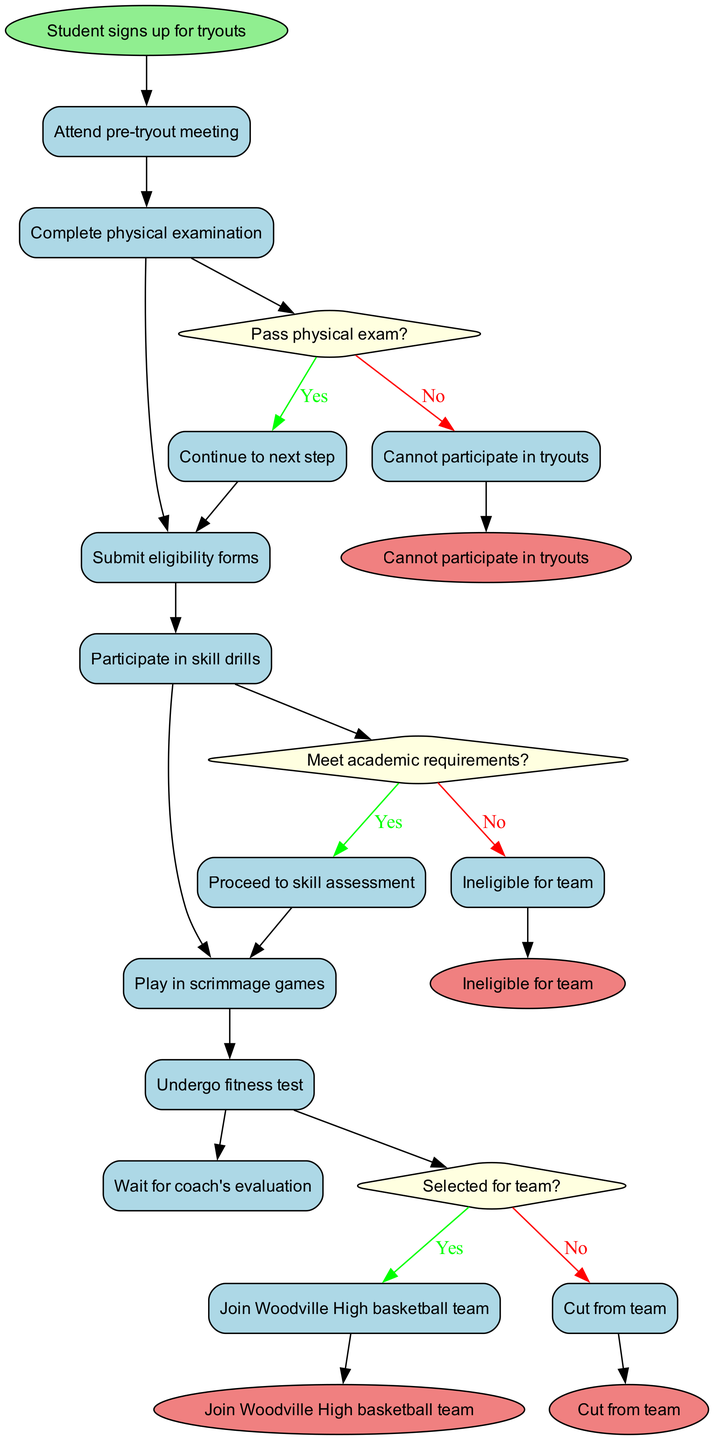What is the starting node of the process? The starting node is defined at the beginning of the diagram, labeled "Student signs up for tryouts."
Answer: Student signs up for tryouts How many activities are listed in the diagram? The activities section includes a list of seven activities, counted directly from the diagram.
Answer: 7 What happens if a student does not pass the physical examination? According to the decision in the diagram, if the physical exam is not passed, the student cannot participate in tryouts, representing a direct flow from that decision.
Answer: Cannot participate in tryouts What is the final outcome for a student who is selected for the team? The final outcome for a selected student, as indicated on the diagram, is joining the Woodville High basketball team.
Answer: Join Woodville High basketball team Which activity directly follows attending the pre-tryout meeting? After attending the pre-tryout meeting, the next activity is completing the physical examination, clearly denoted by the flow of activities in the diagram.
Answer: Complete physical examination What are the consequences if a student fails to meet academic requirements? The diagram specifies that if a student does not meet academic requirements, they become ineligible for the team, following the corresponding decision path.
Answer: Ineligible for team At which decision point does the selection for the team take place? The selection for the team occurs at the third decision point in the diagram, where it asks, "Selected for team?" and branches off accordingly.
Answer: Selected for team What color is used to represent the decision nodes? The decision nodes are represented with a light yellow fill color, as specified in the node style definitions.
Answer: Light yellow What are the end nodes depicted in the diagram? The end nodes listed in the diagram are four distinct outcomes, namely, joining the team, being cut from the team, being ineligible, and not participating in tryouts.
Answer: Join Woodville High basketball team, Cut from team, Ineligible for team, Cannot participate in tryouts 